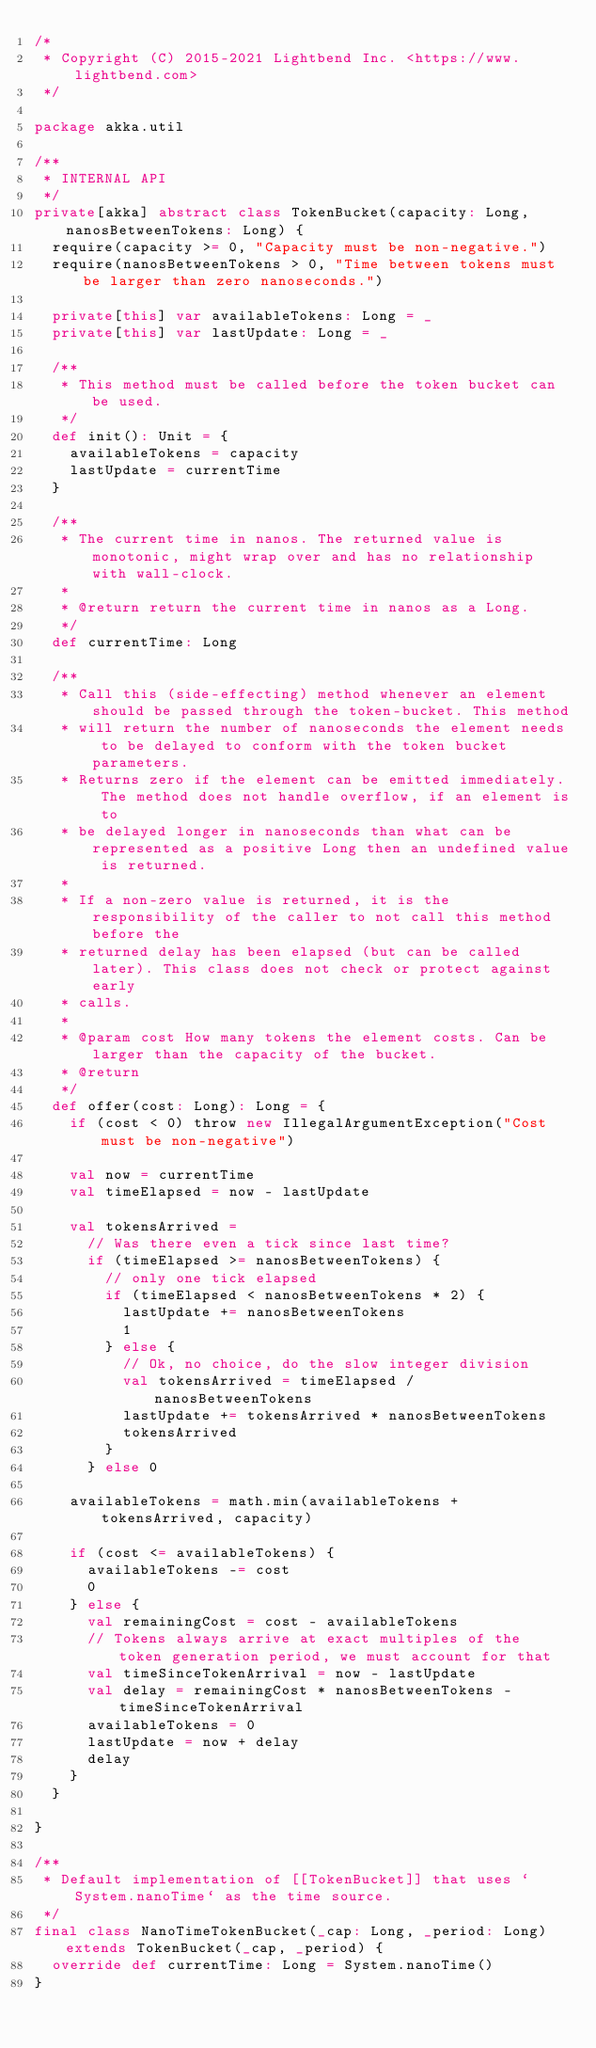<code> <loc_0><loc_0><loc_500><loc_500><_Scala_>/*
 * Copyright (C) 2015-2021 Lightbend Inc. <https://www.lightbend.com>
 */

package akka.util

/**
 * INTERNAL API
 */
private[akka] abstract class TokenBucket(capacity: Long, nanosBetweenTokens: Long) {
  require(capacity >= 0, "Capacity must be non-negative.")
  require(nanosBetweenTokens > 0, "Time between tokens must be larger than zero nanoseconds.")

  private[this] var availableTokens: Long = _
  private[this] var lastUpdate: Long = _

  /**
   * This method must be called before the token bucket can be used.
   */
  def init(): Unit = {
    availableTokens = capacity
    lastUpdate = currentTime
  }

  /**
   * The current time in nanos. The returned value is monotonic, might wrap over and has no relationship with wall-clock.
   *
   * @return return the current time in nanos as a Long.
   */
  def currentTime: Long

  /**
   * Call this (side-effecting) method whenever an element should be passed through the token-bucket. This method
   * will return the number of nanoseconds the element needs to be delayed to conform with the token bucket parameters.
   * Returns zero if the element can be emitted immediately. The method does not handle overflow, if an element is to
   * be delayed longer in nanoseconds than what can be represented as a positive Long then an undefined value is returned.
   *
   * If a non-zero value is returned, it is the responsibility of the caller to not call this method before the
   * returned delay has been elapsed (but can be called later). This class does not check or protect against early
   * calls.
   *
   * @param cost How many tokens the element costs. Can be larger than the capacity of the bucket.
   * @return
   */
  def offer(cost: Long): Long = {
    if (cost < 0) throw new IllegalArgumentException("Cost must be non-negative")

    val now = currentTime
    val timeElapsed = now - lastUpdate

    val tokensArrived =
      // Was there even a tick since last time?
      if (timeElapsed >= nanosBetweenTokens) {
        // only one tick elapsed
        if (timeElapsed < nanosBetweenTokens * 2) {
          lastUpdate += nanosBetweenTokens
          1
        } else {
          // Ok, no choice, do the slow integer division
          val tokensArrived = timeElapsed / nanosBetweenTokens
          lastUpdate += tokensArrived * nanosBetweenTokens
          tokensArrived
        }
      } else 0

    availableTokens = math.min(availableTokens + tokensArrived, capacity)

    if (cost <= availableTokens) {
      availableTokens -= cost
      0
    } else {
      val remainingCost = cost - availableTokens
      // Tokens always arrive at exact multiples of the token generation period, we must account for that
      val timeSinceTokenArrival = now - lastUpdate
      val delay = remainingCost * nanosBetweenTokens - timeSinceTokenArrival
      availableTokens = 0
      lastUpdate = now + delay
      delay
    }
  }

}

/**
 * Default implementation of [[TokenBucket]] that uses `System.nanoTime` as the time source.
 */
final class NanoTimeTokenBucket(_cap: Long, _period: Long) extends TokenBucket(_cap, _period) {
  override def currentTime: Long = System.nanoTime()
}
</code> 